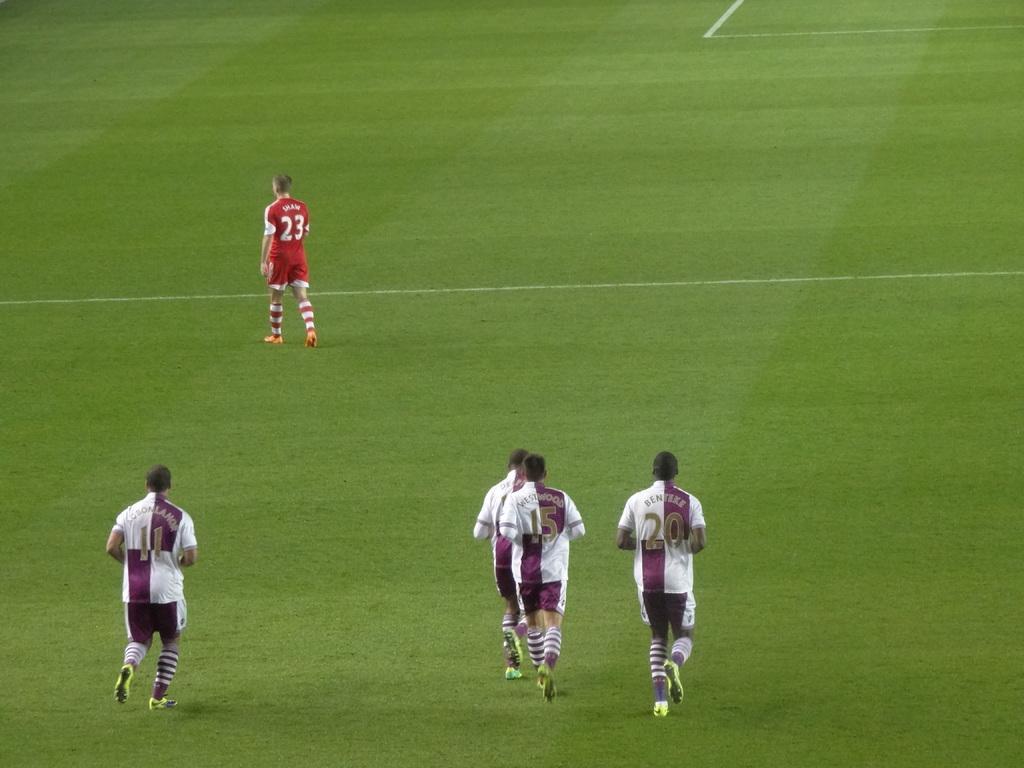Please provide a concise description of this image. In this image there are four football players running on the ground and there is another person in front of them who is wearing the red colour jersey, is walking on the ground. 